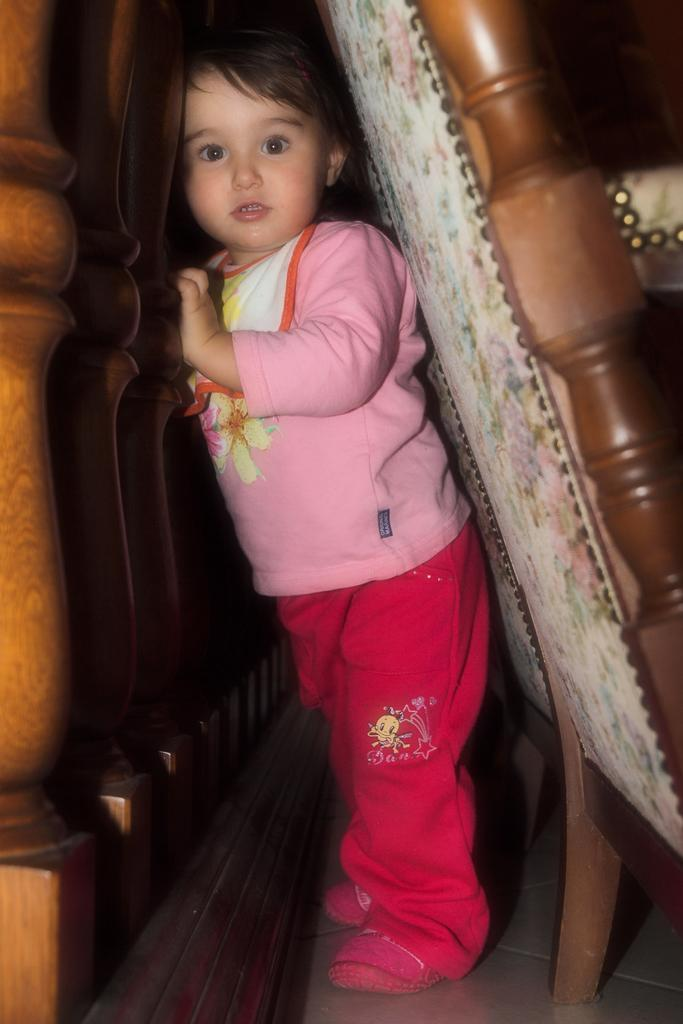What is the main subject of the image? There is a baby in the image. Where is the baby located in the image? The baby is in front of a wooden fence. What other objects can be seen in the image? There are two chairs visible on the right side of the image. What type of sweater is the baby wearing in the image? The image does not show the baby wearing a sweater, so it cannot be determined from the image. 